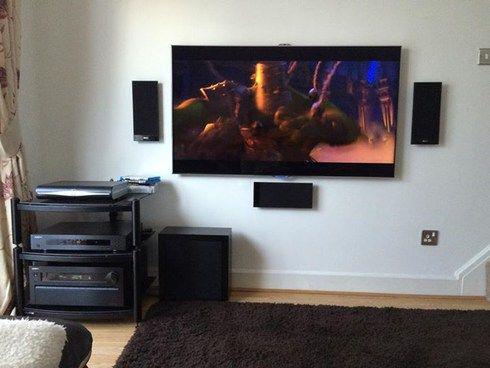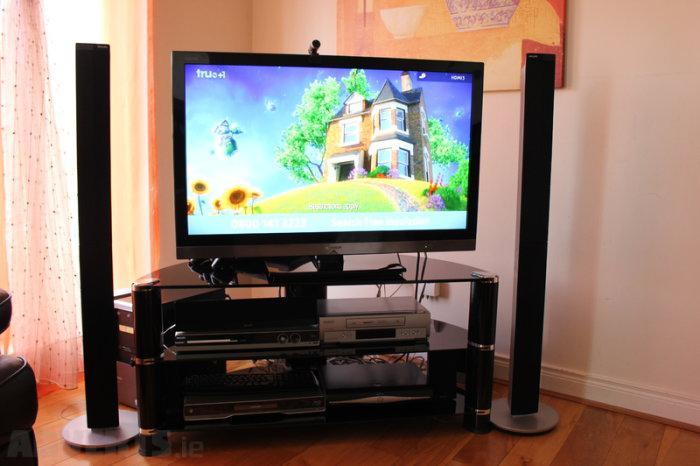The first image is the image on the left, the second image is the image on the right. Considering the images on both sides, is "At least one of the televisions is turned off." valid? Answer yes or no. No. The first image is the image on the left, the second image is the image on the right. Examine the images to the left and right. Is the description "There is nothing playing on at least one of the screens." accurate? Answer yes or no. No. 